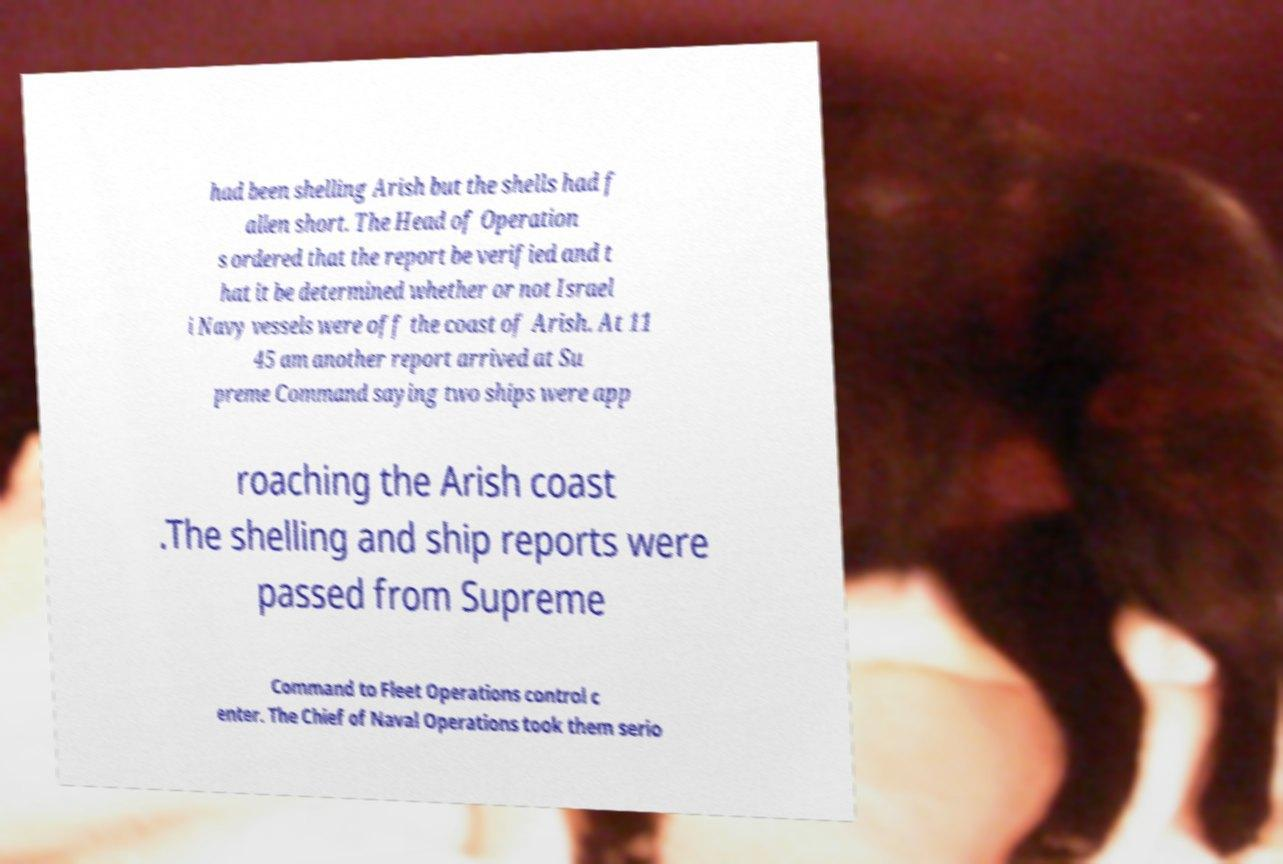Could you assist in decoding the text presented in this image and type it out clearly? had been shelling Arish but the shells had f allen short. The Head of Operation s ordered that the report be verified and t hat it be determined whether or not Israel i Navy vessels were off the coast of Arish. At 11 45 am another report arrived at Su preme Command saying two ships were app roaching the Arish coast .The shelling and ship reports were passed from Supreme Command to Fleet Operations control c enter. The Chief of Naval Operations took them serio 